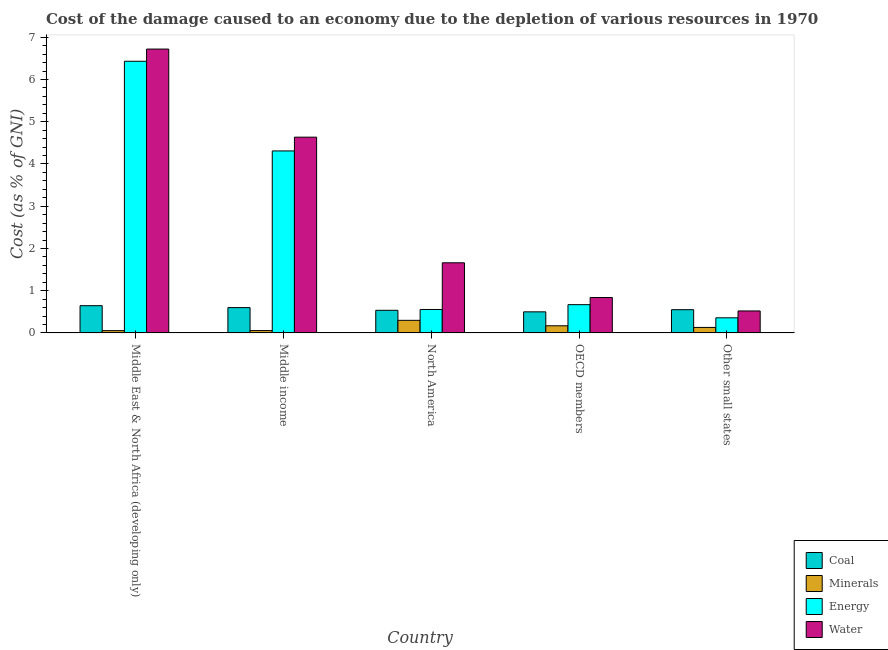How many different coloured bars are there?
Make the answer very short. 4. How many bars are there on the 4th tick from the left?
Make the answer very short. 4. How many bars are there on the 3rd tick from the right?
Make the answer very short. 4. In how many cases, is the number of bars for a given country not equal to the number of legend labels?
Give a very brief answer. 0. What is the cost of damage due to depletion of coal in North America?
Offer a very short reply. 0.54. Across all countries, what is the maximum cost of damage due to depletion of water?
Make the answer very short. 6.72. Across all countries, what is the minimum cost of damage due to depletion of coal?
Offer a very short reply. 0.5. In which country was the cost of damage due to depletion of energy maximum?
Offer a very short reply. Middle East & North Africa (developing only). In which country was the cost of damage due to depletion of coal minimum?
Your answer should be very brief. OECD members. What is the total cost of damage due to depletion of water in the graph?
Keep it short and to the point. 14.38. What is the difference between the cost of damage due to depletion of water in North America and that in OECD members?
Keep it short and to the point. 0.82. What is the difference between the cost of damage due to depletion of water in Middle income and the cost of damage due to depletion of energy in Other small states?
Your response must be concise. 4.28. What is the average cost of damage due to depletion of water per country?
Your response must be concise. 2.88. What is the difference between the cost of damage due to depletion of minerals and cost of damage due to depletion of water in Middle income?
Provide a short and direct response. -4.58. In how many countries, is the cost of damage due to depletion of water greater than 0.8 %?
Make the answer very short. 4. What is the ratio of the cost of damage due to depletion of minerals in OECD members to that in Other small states?
Give a very brief answer. 1.3. Is the cost of damage due to depletion of energy in North America less than that in OECD members?
Keep it short and to the point. Yes. What is the difference between the highest and the second highest cost of damage due to depletion of minerals?
Ensure brevity in your answer.  0.13. What is the difference between the highest and the lowest cost of damage due to depletion of coal?
Your answer should be compact. 0.15. Is it the case that in every country, the sum of the cost of damage due to depletion of coal and cost of damage due to depletion of water is greater than the sum of cost of damage due to depletion of minerals and cost of damage due to depletion of energy?
Ensure brevity in your answer.  No. What does the 3rd bar from the left in Other small states represents?
Your answer should be very brief. Energy. What does the 4th bar from the right in North America represents?
Offer a terse response. Coal. What is the difference between two consecutive major ticks on the Y-axis?
Your answer should be compact. 1. Are the values on the major ticks of Y-axis written in scientific E-notation?
Ensure brevity in your answer.  No. Does the graph contain any zero values?
Your answer should be very brief. No. Does the graph contain grids?
Provide a succinct answer. No. Where does the legend appear in the graph?
Your answer should be very brief. Bottom right. What is the title of the graph?
Give a very brief answer. Cost of the damage caused to an economy due to the depletion of various resources in 1970 . What is the label or title of the X-axis?
Ensure brevity in your answer.  Country. What is the label or title of the Y-axis?
Provide a succinct answer. Cost (as % of GNI). What is the Cost (as % of GNI) in Coal in Middle East & North Africa (developing only)?
Your response must be concise. 0.65. What is the Cost (as % of GNI) of Minerals in Middle East & North Africa (developing only)?
Provide a succinct answer. 0.05. What is the Cost (as % of GNI) in Energy in Middle East & North Africa (developing only)?
Provide a succinct answer. 6.43. What is the Cost (as % of GNI) in Water in Middle East & North Africa (developing only)?
Your response must be concise. 6.72. What is the Cost (as % of GNI) of Coal in Middle income?
Your answer should be compact. 0.6. What is the Cost (as % of GNI) in Minerals in Middle income?
Give a very brief answer. 0.06. What is the Cost (as % of GNI) of Energy in Middle income?
Offer a terse response. 4.31. What is the Cost (as % of GNI) of Water in Middle income?
Your answer should be compact. 4.63. What is the Cost (as % of GNI) of Coal in North America?
Keep it short and to the point. 0.54. What is the Cost (as % of GNI) of Minerals in North America?
Ensure brevity in your answer.  0.3. What is the Cost (as % of GNI) in Energy in North America?
Your response must be concise. 0.56. What is the Cost (as % of GNI) in Water in North America?
Offer a terse response. 1.66. What is the Cost (as % of GNI) in Coal in OECD members?
Ensure brevity in your answer.  0.5. What is the Cost (as % of GNI) in Minerals in OECD members?
Provide a succinct answer. 0.17. What is the Cost (as % of GNI) of Energy in OECD members?
Make the answer very short. 0.67. What is the Cost (as % of GNI) in Water in OECD members?
Offer a terse response. 0.84. What is the Cost (as % of GNI) in Coal in Other small states?
Keep it short and to the point. 0.55. What is the Cost (as % of GNI) in Minerals in Other small states?
Provide a succinct answer. 0.13. What is the Cost (as % of GNI) of Energy in Other small states?
Your answer should be compact. 0.36. What is the Cost (as % of GNI) in Water in Other small states?
Offer a terse response. 0.52. Across all countries, what is the maximum Cost (as % of GNI) in Coal?
Your answer should be compact. 0.65. Across all countries, what is the maximum Cost (as % of GNI) of Minerals?
Your response must be concise. 0.3. Across all countries, what is the maximum Cost (as % of GNI) of Energy?
Your answer should be compact. 6.43. Across all countries, what is the maximum Cost (as % of GNI) of Water?
Offer a terse response. 6.72. Across all countries, what is the minimum Cost (as % of GNI) of Coal?
Provide a short and direct response. 0.5. Across all countries, what is the minimum Cost (as % of GNI) of Minerals?
Provide a short and direct response. 0.05. Across all countries, what is the minimum Cost (as % of GNI) in Energy?
Give a very brief answer. 0.36. Across all countries, what is the minimum Cost (as % of GNI) in Water?
Offer a very short reply. 0.52. What is the total Cost (as % of GNI) of Coal in the graph?
Your answer should be very brief. 2.83. What is the total Cost (as % of GNI) of Minerals in the graph?
Your response must be concise. 0.71. What is the total Cost (as % of GNI) of Energy in the graph?
Your answer should be compact. 12.32. What is the total Cost (as % of GNI) in Water in the graph?
Offer a terse response. 14.38. What is the difference between the Cost (as % of GNI) of Coal in Middle East & North Africa (developing only) and that in Middle income?
Give a very brief answer. 0.05. What is the difference between the Cost (as % of GNI) of Minerals in Middle East & North Africa (developing only) and that in Middle income?
Your answer should be very brief. -0. What is the difference between the Cost (as % of GNI) in Energy in Middle East & North Africa (developing only) and that in Middle income?
Your response must be concise. 2.12. What is the difference between the Cost (as % of GNI) of Water in Middle East & North Africa (developing only) and that in Middle income?
Provide a short and direct response. 2.09. What is the difference between the Cost (as % of GNI) of Coal in Middle East & North Africa (developing only) and that in North America?
Provide a short and direct response. 0.11. What is the difference between the Cost (as % of GNI) of Minerals in Middle East & North Africa (developing only) and that in North America?
Your answer should be very brief. -0.24. What is the difference between the Cost (as % of GNI) of Energy in Middle East & North Africa (developing only) and that in North America?
Keep it short and to the point. 5.88. What is the difference between the Cost (as % of GNI) of Water in Middle East & North Africa (developing only) and that in North America?
Offer a very short reply. 5.06. What is the difference between the Cost (as % of GNI) of Coal in Middle East & North Africa (developing only) and that in OECD members?
Your answer should be compact. 0.15. What is the difference between the Cost (as % of GNI) of Minerals in Middle East & North Africa (developing only) and that in OECD members?
Your response must be concise. -0.11. What is the difference between the Cost (as % of GNI) of Energy in Middle East & North Africa (developing only) and that in OECD members?
Your answer should be compact. 5.76. What is the difference between the Cost (as % of GNI) of Water in Middle East & North Africa (developing only) and that in OECD members?
Your response must be concise. 5.88. What is the difference between the Cost (as % of GNI) in Coal in Middle East & North Africa (developing only) and that in Other small states?
Provide a succinct answer. 0.09. What is the difference between the Cost (as % of GNI) of Minerals in Middle East & North Africa (developing only) and that in Other small states?
Your answer should be compact. -0.08. What is the difference between the Cost (as % of GNI) of Energy in Middle East & North Africa (developing only) and that in Other small states?
Your answer should be very brief. 6.07. What is the difference between the Cost (as % of GNI) of Water in Middle East & North Africa (developing only) and that in Other small states?
Offer a very short reply. 6.2. What is the difference between the Cost (as % of GNI) of Coal in Middle income and that in North America?
Make the answer very short. 0.06. What is the difference between the Cost (as % of GNI) in Minerals in Middle income and that in North America?
Provide a short and direct response. -0.24. What is the difference between the Cost (as % of GNI) in Energy in Middle income and that in North America?
Make the answer very short. 3.75. What is the difference between the Cost (as % of GNI) in Water in Middle income and that in North America?
Offer a terse response. 2.97. What is the difference between the Cost (as % of GNI) of Coal in Middle income and that in OECD members?
Your answer should be very brief. 0.1. What is the difference between the Cost (as % of GNI) in Minerals in Middle income and that in OECD members?
Give a very brief answer. -0.11. What is the difference between the Cost (as % of GNI) of Energy in Middle income and that in OECD members?
Ensure brevity in your answer.  3.64. What is the difference between the Cost (as % of GNI) of Water in Middle income and that in OECD members?
Offer a terse response. 3.8. What is the difference between the Cost (as % of GNI) in Coal in Middle income and that in Other small states?
Give a very brief answer. 0.05. What is the difference between the Cost (as % of GNI) of Minerals in Middle income and that in Other small states?
Provide a short and direct response. -0.07. What is the difference between the Cost (as % of GNI) in Energy in Middle income and that in Other small states?
Offer a terse response. 3.95. What is the difference between the Cost (as % of GNI) of Water in Middle income and that in Other small states?
Your answer should be very brief. 4.11. What is the difference between the Cost (as % of GNI) of Coal in North America and that in OECD members?
Your answer should be compact. 0.04. What is the difference between the Cost (as % of GNI) of Minerals in North America and that in OECD members?
Give a very brief answer. 0.13. What is the difference between the Cost (as % of GNI) in Energy in North America and that in OECD members?
Provide a succinct answer. -0.11. What is the difference between the Cost (as % of GNI) of Water in North America and that in OECD members?
Give a very brief answer. 0.82. What is the difference between the Cost (as % of GNI) in Coal in North America and that in Other small states?
Your response must be concise. -0.01. What is the difference between the Cost (as % of GNI) of Minerals in North America and that in Other small states?
Your answer should be very brief. 0.17. What is the difference between the Cost (as % of GNI) in Energy in North America and that in Other small states?
Provide a succinct answer. 0.2. What is the difference between the Cost (as % of GNI) in Water in North America and that in Other small states?
Provide a succinct answer. 1.14. What is the difference between the Cost (as % of GNI) of Coal in OECD members and that in Other small states?
Make the answer very short. -0.05. What is the difference between the Cost (as % of GNI) of Minerals in OECD members and that in Other small states?
Ensure brevity in your answer.  0.04. What is the difference between the Cost (as % of GNI) of Energy in OECD members and that in Other small states?
Offer a very short reply. 0.31. What is the difference between the Cost (as % of GNI) in Water in OECD members and that in Other small states?
Your answer should be compact. 0.32. What is the difference between the Cost (as % of GNI) in Coal in Middle East & North Africa (developing only) and the Cost (as % of GNI) in Minerals in Middle income?
Your answer should be compact. 0.59. What is the difference between the Cost (as % of GNI) in Coal in Middle East & North Africa (developing only) and the Cost (as % of GNI) in Energy in Middle income?
Keep it short and to the point. -3.66. What is the difference between the Cost (as % of GNI) of Coal in Middle East & North Africa (developing only) and the Cost (as % of GNI) of Water in Middle income?
Offer a terse response. -3.99. What is the difference between the Cost (as % of GNI) in Minerals in Middle East & North Africa (developing only) and the Cost (as % of GNI) in Energy in Middle income?
Provide a succinct answer. -4.25. What is the difference between the Cost (as % of GNI) of Minerals in Middle East & North Africa (developing only) and the Cost (as % of GNI) of Water in Middle income?
Make the answer very short. -4.58. What is the difference between the Cost (as % of GNI) of Energy in Middle East & North Africa (developing only) and the Cost (as % of GNI) of Water in Middle income?
Keep it short and to the point. 1.8. What is the difference between the Cost (as % of GNI) in Coal in Middle East & North Africa (developing only) and the Cost (as % of GNI) in Minerals in North America?
Provide a short and direct response. 0.35. What is the difference between the Cost (as % of GNI) in Coal in Middle East & North Africa (developing only) and the Cost (as % of GNI) in Energy in North America?
Ensure brevity in your answer.  0.09. What is the difference between the Cost (as % of GNI) in Coal in Middle East & North Africa (developing only) and the Cost (as % of GNI) in Water in North America?
Give a very brief answer. -1.02. What is the difference between the Cost (as % of GNI) of Minerals in Middle East & North Africa (developing only) and the Cost (as % of GNI) of Energy in North America?
Provide a short and direct response. -0.5. What is the difference between the Cost (as % of GNI) of Minerals in Middle East & North Africa (developing only) and the Cost (as % of GNI) of Water in North America?
Give a very brief answer. -1.61. What is the difference between the Cost (as % of GNI) in Energy in Middle East & North Africa (developing only) and the Cost (as % of GNI) in Water in North America?
Your answer should be very brief. 4.77. What is the difference between the Cost (as % of GNI) of Coal in Middle East & North Africa (developing only) and the Cost (as % of GNI) of Minerals in OECD members?
Offer a terse response. 0.48. What is the difference between the Cost (as % of GNI) in Coal in Middle East & North Africa (developing only) and the Cost (as % of GNI) in Energy in OECD members?
Your response must be concise. -0.02. What is the difference between the Cost (as % of GNI) in Coal in Middle East & North Africa (developing only) and the Cost (as % of GNI) in Water in OECD members?
Your answer should be compact. -0.19. What is the difference between the Cost (as % of GNI) of Minerals in Middle East & North Africa (developing only) and the Cost (as % of GNI) of Energy in OECD members?
Ensure brevity in your answer.  -0.61. What is the difference between the Cost (as % of GNI) in Minerals in Middle East & North Africa (developing only) and the Cost (as % of GNI) in Water in OECD members?
Your response must be concise. -0.78. What is the difference between the Cost (as % of GNI) of Energy in Middle East & North Africa (developing only) and the Cost (as % of GNI) of Water in OECD members?
Your answer should be compact. 5.59. What is the difference between the Cost (as % of GNI) in Coal in Middle East & North Africa (developing only) and the Cost (as % of GNI) in Minerals in Other small states?
Your answer should be very brief. 0.52. What is the difference between the Cost (as % of GNI) of Coal in Middle East & North Africa (developing only) and the Cost (as % of GNI) of Energy in Other small states?
Offer a very short reply. 0.29. What is the difference between the Cost (as % of GNI) in Coal in Middle East & North Africa (developing only) and the Cost (as % of GNI) in Water in Other small states?
Provide a short and direct response. 0.12. What is the difference between the Cost (as % of GNI) of Minerals in Middle East & North Africa (developing only) and the Cost (as % of GNI) of Energy in Other small states?
Your answer should be compact. -0.3. What is the difference between the Cost (as % of GNI) of Minerals in Middle East & North Africa (developing only) and the Cost (as % of GNI) of Water in Other small states?
Give a very brief answer. -0.47. What is the difference between the Cost (as % of GNI) of Energy in Middle East & North Africa (developing only) and the Cost (as % of GNI) of Water in Other small states?
Provide a short and direct response. 5.91. What is the difference between the Cost (as % of GNI) of Coal in Middle income and the Cost (as % of GNI) of Minerals in North America?
Your answer should be compact. 0.3. What is the difference between the Cost (as % of GNI) of Coal in Middle income and the Cost (as % of GNI) of Energy in North America?
Offer a very short reply. 0.04. What is the difference between the Cost (as % of GNI) of Coal in Middle income and the Cost (as % of GNI) of Water in North America?
Your answer should be very brief. -1.06. What is the difference between the Cost (as % of GNI) in Minerals in Middle income and the Cost (as % of GNI) in Energy in North America?
Your answer should be very brief. -0.5. What is the difference between the Cost (as % of GNI) of Minerals in Middle income and the Cost (as % of GNI) of Water in North America?
Provide a succinct answer. -1.6. What is the difference between the Cost (as % of GNI) in Energy in Middle income and the Cost (as % of GNI) in Water in North America?
Your response must be concise. 2.65. What is the difference between the Cost (as % of GNI) of Coal in Middle income and the Cost (as % of GNI) of Minerals in OECD members?
Give a very brief answer. 0.43. What is the difference between the Cost (as % of GNI) in Coal in Middle income and the Cost (as % of GNI) in Energy in OECD members?
Give a very brief answer. -0.07. What is the difference between the Cost (as % of GNI) of Coal in Middle income and the Cost (as % of GNI) of Water in OECD members?
Your answer should be compact. -0.24. What is the difference between the Cost (as % of GNI) of Minerals in Middle income and the Cost (as % of GNI) of Energy in OECD members?
Offer a very short reply. -0.61. What is the difference between the Cost (as % of GNI) in Minerals in Middle income and the Cost (as % of GNI) in Water in OECD members?
Your response must be concise. -0.78. What is the difference between the Cost (as % of GNI) in Energy in Middle income and the Cost (as % of GNI) in Water in OECD members?
Your response must be concise. 3.47. What is the difference between the Cost (as % of GNI) of Coal in Middle income and the Cost (as % of GNI) of Minerals in Other small states?
Make the answer very short. 0.47. What is the difference between the Cost (as % of GNI) of Coal in Middle income and the Cost (as % of GNI) of Energy in Other small states?
Your response must be concise. 0.24. What is the difference between the Cost (as % of GNI) of Coal in Middle income and the Cost (as % of GNI) of Water in Other small states?
Provide a short and direct response. 0.08. What is the difference between the Cost (as % of GNI) in Minerals in Middle income and the Cost (as % of GNI) in Energy in Other small states?
Provide a succinct answer. -0.3. What is the difference between the Cost (as % of GNI) of Minerals in Middle income and the Cost (as % of GNI) of Water in Other small states?
Provide a succinct answer. -0.46. What is the difference between the Cost (as % of GNI) in Energy in Middle income and the Cost (as % of GNI) in Water in Other small states?
Provide a succinct answer. 3.79. What is the difference between the Cost (as % of GNI) of Coal in North America and the Cost (as % of GNI) of Minerals in OECD members?
Provide a succinct answer. 0.37. What is the difference between the Cost (as % of GNI) of Coal in North America and the Cost (as % of GNI) of Energy in OECD members?
Ensure brevity in your answer.  -0.13. What is the difference between the Cost (as % of GNI) in Coal in North America and the Cost (as % of GNI) in Water in OECD members?
Offer a very short reply. -0.3. What is the difference between the Cost (as % of GNI) in Minerals in North America and the Cost (as % of GNI) in Energy in OECD members?
Give a very brief answer. -0.37. What is the difference between the Cost (as % of GNI) in Minerals in North America and the Cost (as % of GNI) in Water in OECD members?
Offer a terse response. -0.54. What is the difference between the Cost (as % of GNI) in Energy in North America and the Cost (as % of GNI) in Water in OECD members?
Keep it short and to the point. -0.28. What is the difference between the Cost (as % of GNI) of Coal in North America and the Cost (as % of GNI) of Minerals in Other small states?
Offer a terse response. 0.41. What is the difference between the Cost (as % of GNI) in Coal in North America and the Cost (as % of GNI) in Energy in Other small states?
Your response must be concise. 0.18. What is the difference between the Cost (as % of GNI) of Coal in North America and the Cost (as % of GNI) of Water in Other small states?
Your answer should be compact. 0.01. What is the difference between the Cost (as % of GNI) of Minerals in North America and the Cost (as % of GNI) of Energy in Other small states?
Provide a succinct answer. -0.06. What is the difference between the Cost (as % of GNI) of Minerals in North America and the Cost (as % of GNI) of Water in Other small states?
Provide a succinct answer. -0.22. What is the difference between the Cost (as % of GNI) of Energy in North America and the Cost (as % of GNI) of Water in Other small states?
Give a very brief answer. 0.03. What is the difference between the Cost (as % of GNI) of Coal in OECD members and the Cost (as % of GNI) of Minerals in Other small states?
Ensure brevity in your answer.  0.37. What is the difference between the Cost (as % of GNI) of Coal in OECD members and the Cost (as % of GNI) of Energy in Other small states?
Your answer should be compact. 0.14. What is the difference between the Cost (as % of GNI) in Coal in OECD members and the Cost (as % of GNI) in Water in Other small states?
Your response must be concise. -0.02. What is the difference between the Cost (as % of GNI) of Minerals in OECD members and the Cost (as % of GNI) of Energy in Other small states?
Ensure brevity in your answer.  -0.19. What is the difference between the Cost (as % of GNI) in Minerals in OECD members and the Cost (as % of GNI) in Water in Other small states?
Offer a terse response. -0.35. What is the difference between the Cost (as % of GNI) of Energy in OECD members and the Cost (as % of GNI) of Water in Other small states?
Your answer should be very brief. 0.15. What is the average Cost (as % of GNI) of Coal per country?
Your response must be concise. 0.57. What is the average Cost (as % of GNI) in Minerals per country?
Your response must be concise. 0.14. What is the average Cost (as % of GNI) in Energy per country?
Provide a short and direct response. 2.46. What is the average Cost (as % of GNI) of Water per country?
Your answer should be very brief. 2.88. What is the difference between the Cost (as % of GNI) in Coal and Cost (as % of GNI) in Minerals in Middle East & North Africa (developing only)?
Ensure brevity in your answer.  0.59. What is the difference between the Cost (as % of GNI) in Coal and Cost (as % of GNI) in Energy in Middle East & North Africa (developing only)?
Your answer should be very brief. -5.79. What is the difference between the Cost (as % of GNI) in Coal and Cost (as % of GNI) in Water in Middle East & North Africa (developing only)?
Ensure brevity in your answer.  -6.08. What is the difference between the Cost (as % of GNI) of Minerals and Cost (as % of GNI) of Energy in Middle East & North Africa (developing only)?
Give a very brief answer. -6.38. What is the difference between the Cost (as % of GNI) in Minerals and Cost (as % of GNI) in Water in Middle East & North Africa (developing only)?
Ensure brevity in your answer.  -6.67. What is the difference between the Cost (as % of GNI) of Energy and Cost (as % of GNI) of Water in Middle East & North Africa (developing only)?
Offer a very short reply. -0.29. What is the difference between the Cost (as % of GNI) of Coal and Cost (as % of GNI) of Minerals in Middle income?
Keep it short and to the point. 0.54. What is the difference between the Cost (as % of GNI) of Coal and Cost (as % of GNI) of Energy in Middle income?
Your answer should be very brief. -3.71. What is the difference between the Cost (as % of GNI) in Coal and Cost (as % of GNI) in Water in Middle income?
Provide a succinct answer. -4.03. What is the difference between the Cost (as % of GNI) in Minerals and Cost (as % of GNI) in Energy in Middle income?
Provide a succinct answer. -4.25. What is the difference between the Cost (as % of GNI) of Minerals and Cost (as % of GNI) of Water in Middle income?
Ensure brevity in your answer.  -4.58. What is the difference between the Cost (as % of GNI) in Energy and Cost (as % of GNI) in Water in Middle income?
Make the answer very short. -0.33. What is the difference between the Cost (as % of GNI) in Coal and Cost (as % of GNI) in Minerals in North America?
Your answer should be very brief. 0.24. What is the difference between the Cost (as % of GNI) of Coal and Cost (as % of GNI) of Energy in North America?
Offer a terse response. -0.02. What is the difference between the Cost (as % of GNI) in Coal and Cost (as % of GNI) in Water in North America?
Offer a very short reply. -1.12. What is the difference between the Cost (as % of GNI) of Minerals and Cost (as % of GNI) of Energy in North America?
Provide a short and direct response. -0.26. What is the difference between the Cost (as % of GNI) of Minerals and Cost (as % of GNI) of Water in North America?
Provide a succinct answer. -1.36. What is the difference between the Cost (as % of GNI) in Energy and Cost (as % of GNI) in Water in North America?
Your response must be concise. -1.11. What is the difference between the Cost (as % of GNI) of Coal and Cost (as % of GNI) of Minerals in OECD members?
Offer a terse response. 0.33. What is the difference between the Cost (as % of GNI) of Coal and Cost (as % of GNI) of Energy in OECD members?
Provide a short and direct response. -0.17. What is the difference between the Cost (as % of GNI) of Coal and Cost (as % of GNI) of Water in OECD members?
Your response must be concise. -0.34. What is the difference between the Cost (as % of GNI) in Minerals and Cost (as % of GNI) in Energy in OECD members?
Your response must be concise. -0.5. What is the difference between the Cost (as % of GNI) in Minerals and Cost (as % of GNI) in Water in OECD members?
Ensure brevity in your answer.  -0.67. What is the difference between the Cost (as % of GNI) in Energy and Cost (as % of GNI) in Water in OECD members?
Offer a very short reply. -0.17. What is the difference between the Cost (as % of GNI) in Coal and Cost (as % of GNI) in Minerals in Other small states?
Your response must be concise. 0.42. What is the difference between the Cost (as % of GNI) in Coal and Cost (as % of GNI) in Energy in Other small states?
Your answer should be compact. 0.19. What is the difference between the Cost (as % of GNI) in Coal and Cost (as % of GNI) in Water in Other small states?
Provide a short and direct response. 0.03. What is the difference between the Cost (as % of GNI) in Minerals and Cost (as % of GNI) in Energy in Other small states?
Give a very brief answer. -0.23. What is the difference between the Cost (as % of GNI) of Minerals and Cost (as % of GNI) of Water in Other small states?
Your answer should be compact. -0.39. What is the difference between the Cost (as % of GNI) of Energy and Cost (as % of GNI) of Water in Other small states?
Your response must be concise. -0.16. What is the ratio of the Cost (as % of GNI) in Coal in Middle East & North Africa (developing only) to that in Middle income?
Give a very brief answer. 1.08. What is the ratio of the Cost (as % of GNI) in Minerals in Middle East & North Africa (developing only) to that in Middle income?
Provide a short and direct response. 0.97. What is the ratio of the Cost (as % of GNI) in Energy in Middle East & North Africa (developing only) to that in Middle income?
Offer a very short reply. 1.49. What is the ratio of the Cost (as % of GNI) of Water in Middle East & North Africa (developing only) to that in Middle income?
Your response must be concise. 1.45. What is the ratio of the Cost (as % of GNI) of Coal in Middle East & North Africa (developing only) to that in North America?
Keep it short and to the point. 1.2. What is the ratio of the Cost (as % of GNI) in Minerals in Middle East & North Africa (developing only) to that in North America?
Your answer should be very brief. 0.18. What is the ratio of the Cost (as % of GNI) of Energy in Middle East & North Africa (developing only) to that in North America?
Your answer should be compact. 11.58. What is the ratio of the Cost (as % of GNI) in Water in Middle East & North Africa (developing only) to that in North America?
Provide a succinct answer. 4.05. What is the ratio of the Cost (as % of GNI) in Coal in Middle East & North Africa (developing only) to that in OECD members?
Your answer should be compact. 1.29. What is the ratio of the Cost (as % of GNI) in Minerals in Middle East & North Africa (developing only) to that in OECD members?
Give a very brief answer. 0.32. What is the ratio of the Cost (as % of GNI) in Energy in Middle East & North Africa (developing only) to that in OECD members?
Offer a terse response. 9.61. What is the ratio of the Cost (as % of GNI) of Water in Middle East & North Africa (developing only) to that in OECD members?
Give a very brief answer. 8.01. What is the ratio of the Cost (as % of GNI) of Coal in Middle East & North Africa (developing only) to that in Other small states?
Make the answer very short. 1.17. What is the ratio of the Cost (as % of GNI) in Minerals in Middle East & North Africa (developing only) to that in Other small states?
Your response must be concise. 0.42. What is the ratio of the Cost (as % of GNI) in Energy in Middle East & North Africa (developing only) to that in Other small states?
Your response must be concise. 17.96. What is the ratio of the Cost (as % of GNI) in Water in Middle East & North Africa (developing only) to that in Other small states?
Offer a terse response. 12.9. What is the ratio of the Cost (as % of GNI) of Coal in Middle income to that in North America?
Your answer should be very brief. 1.12. What is the ratio of the Cost (as % of GNI) in Minerals in Middle income to that in North America?
Make the answer very short. 0.19. What is the ratio of the Cost (as % of GNI) in Energy in Middle income to that in North America?
Keep it short and to the point. 7.76. What is the ratio of the Cost (as % of GNI) in Water in Middle income to that in North America?
Ensure brevity in your answer.  2.79. What is the ratio of the Cost (as % of GNI) of Coal in Middle income to that in OECD members?
Your answer should be compact. 1.2. What is the ratio of the Cost (as % of GNI) of Minerals in Middle income to that in OECD members?
Offer a terse response. 0.33. What is the ratio of the Cost (as % of GNI) of Energy in Middle income to that in OECD members?
Offer a terse response. 6.44. What is the ratio of the Cost (as % of GNI) of Water in Middle income to that in OECD members?
Offer a terse response. 5.53. What is the ratio of the Cost (as % of GNI) of Coal in Middle income to that in Other small states?
Your response must be concise. 1.09. What is the ratio of the Cost (as % of GNI) of Minerals in Middle income to that in Other small states?
Provide a short and direct response. 0.43. What is the ratio of the Cost (as % of GNI) of Energy in Middle income to that in Other small states?
Make the answer very short. 12.03. What is the ratio of the Cost (as % of GNI) of Water in Middle income to that in Other small states?
Provide a short and direct response. 8.9. What is the ratio of the Cost (as % of GNI) in Coal in North America to that in OECD members?
Provide a short and direct response. 1.07. What is the ratio of the Cost (as % of GNI) in Minerals in North America to that in OECD members?
Your response must be concise. 1.76. What is the ratio of the Cost (as % of GNI) in Energy in North America to that in OECD members?
Keep it short and to the point. 0.83. What is the ratio of the Cost (as % of GNI) in Water in North America to that in OECD members?
Give a very brief answer. 1.98. What is the ratio of the Cost (as % of GNI) of Coal in North America to that in Other small states?
Offer a terse response. 0.97. What is the ratio of the Cost (as % of GNI) of Minerals in North America to that in Other small states?
Offer a terse response. 2.29. What is the ratio of the Cost (as % of GNI) in Energy in North America to that in Other small states?
Ensure brevity in your answer.  1.55. What is the ratio of the Cost (as % of GNI) of Water in North America to that in Other small states?
Keep it short and to the point. 3.19. What is the ratio of the Cost (as % of GNI) of Coal in OECD members to that in Other small states?
Your answer should be compact. 0.91. What is the ratio of the Cost (as % of GNI) in Minerals in OECD members to that in Other small states?
Your answer should be compact. 1.3. What is the ratio of the Cost (as % of GNI) in Energy in OECD members to that in Other small states?
Offer a terse response. 1.87. What is the ratio of the Cost (as % of GNI) of Water in OECD members to that in Other small states?
Offer a very short reply. 1.61. What is the difference between the highest and the second highest Cost (as % of GNI) in Coal?
Provide a succinct answer. 0.05. What is the difference between the highest and the second highest Cost (as % of GNI) of Minerals?
Your response must be concise. 0.13. What is the difference between the highest and the second highest Cost (as % of GNI) in Energy?
Provide a short and direct response. 2.12. What is the difference between the highest and the second highest Cost (as % of GNI) in Water?
Your answer should be very brief. 2.09. What is the difference between the highest and the lowest Cost (as % of GNI) of Coal?
Offer a terse response. 0.15. What is the difference between the highest and the lowest Cost (as % of GNI) in Minerals?
Your answer should be very brief. 0.24. What is the difference between the highest and the lowest Cost (as % of GNI) in Energy?
Offer a very short reply. 6.07. What is the difference between the highest and the lowest Cost (as % of GNI) in Water?
Your answer should be compact. 6.2. 